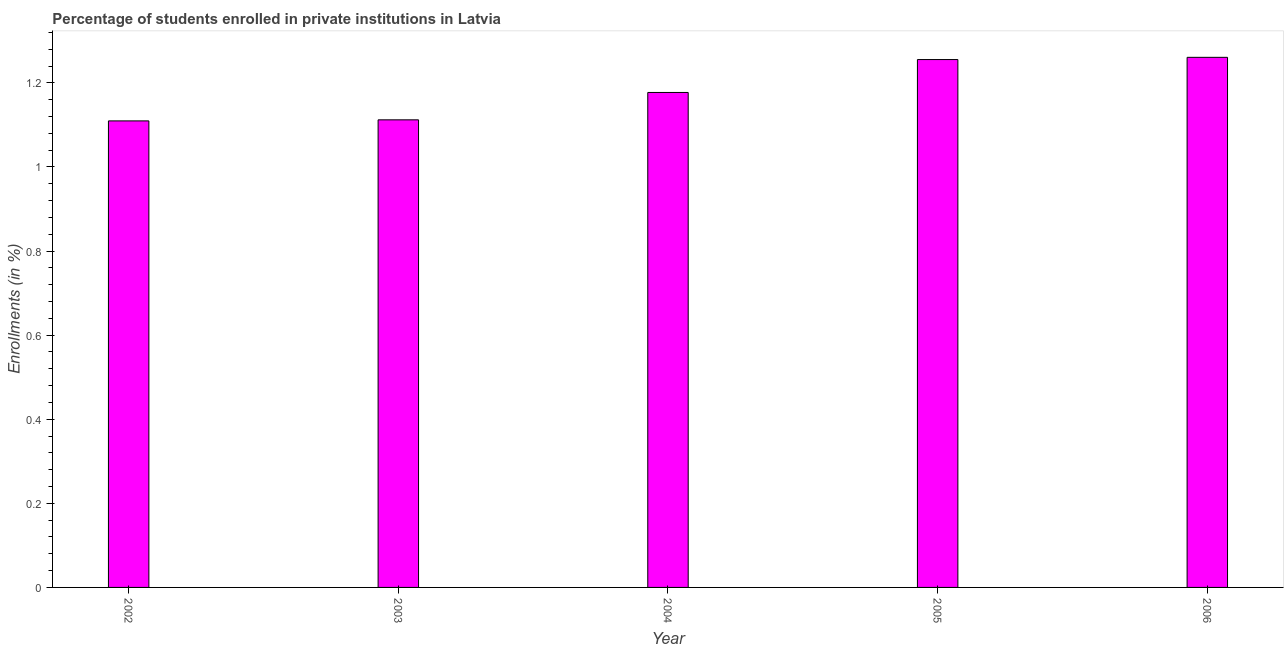What is the title of the graph?
Provide a succinct answer. Percentage of students enrolled in private institutions in Latvia. What is the label or title of the X-axis?
Offer a very short reply. Year. What is the label or title of the Y-axis?
Give a very brief answer. Enrollments (in %). What is the enrollments in private institutions in 2004?
Provide a short and direct response. 1.18. Across all years, what is the maximum enrollments in private institutions?
Your answer should be compact. 1.26. Across all years, what is the minimum enrollments in private institutions?
Make the answer very short. 1.11. In which year was the enrollments in private institutions minimum?
Your answer should be very brief. 2002. What is the sum of the enrollments in private institutions?
Give a very brief answer. 5.91. What is the difference between the enrollments in private institutions in 2002 and 2004?
Your answer should be very brief. -0.07. What is the average enrollments in private institutions per year?
Offer a very short reply. 1.18. What is the median enrollments in private institutions?
Ensure brevity in your answer.  1.18. In how many years, is the enrollments in private institutions greater than 0.32 %?
Give a very brief answer. 5. Do a majority of the years between 2006 and 2004 (inclusive) have enrollments in private institutions greater than 0.84 %?
Offer a very short reply. Yes. What is the ratio of the enrollments in private institutions in 2005 to that in 2006?
Offer a very short reply. 1. Is the enrollments in private institutions in 2002 less than that in 2005?
Your response must be concise. Yes. What is the difference between the highest and the second highest enrollments in private institutions?
Your answer should be compact. 0.01. Is the sum of the enrollments in private institutions in 2002 and 2005 greater than the maximum enrollments in private institutions across all years?
Your answer should be compact. Yes. What is the difference between the highest and the lowest enrollments in private institutions?
Provide a succinct answer. 0.15. Are all the bars in the graph horizontal?
Give a very brief answer. No. What is the difference between two consecutive major ticks on the Y-axis?
Provide a succinct answer. 0.2. What is the Enrollments (in %) of 2002?
Your response must be concise. 1.11. What is the Enrollments (in %) in 2003?
Provide a succinct answer. 1.11. What is the Enrollments (in %) in 2004?
Your answer should be very brief. 1.18. What is the Enrollments (in %) in 2005?
Give a very brief answer. 1.26. What is the Enrollments (in %) of 2006?
Offer a very short reply. 1.26. What is the difference between the Enrollments (in %) in 2002 and 2003?
Provide a short and direct response. -0. What is the difference between the Enrollments (in %) in 2002 and 2004?
Your answer should be compact. -0.07. What is the difference between the Enrollments (in %) in 2002 and 2005?
Your response must be concise. -0.15. What is the difference between the Enrollments (in %) in 2002 and 2006?
Provide a short and direct response. -0.15. What is the difference between the Enrollments (in %) in 2003 and 2004?
Provide a short and direct response. -0.07. What is the difference between the Enrollments (in %) in 2003 and 2005?
Offer a terse response. -0.14. What is the difference between the Enrollments (in %) in 2003 and 2006?
Your answer should be very brief. -0.15. What is the difference between the Enrollments (in %) in 2004 and 2005?
Offer a terse response. -0.08. What is the difference between the Enrollments (in %) in 2004 and 2006?
Make the answer very short. -0.08. What is the difference between the Enrollments (in %) in 2005 and 2006?
Your answer should be compact. -0.01. What is the ratio of the Enrollments (in %) in 2002 to that in 2003?
Provide a succinct answer. 1. What is the ratio of the Enrollments (in %) in 2002 to that in 2004?
Make the answer very short. 0.94. What is the ratio of the Enrollments (in %) in 2002 to that in 2005?
Provide a short and direct response. 0.88. What is the ratio of the Enrollments (in %) in 2003 to that in 2004?
Your answer should be very brief. 0.94. What is the ratio of the Enrollments (in %) in 2003 to that in 2005?
Make the answer very short. 0.89. What is the ratio of the Enrollments (in %) in 2003 to that in 2006?
Provide a short and direct response. 0.88. What is the ratio of the Enrollments (in %) in 2004 to that in 2005?
Keep it short and to the point. 0.94. What is the ratio of the Enrollments (in %) in 2004 to that in 2006?
Your answer should be compact. 0.93. What is the ratio of the Enrollments (in %) in 2005 to that in 2006?
Provide a short and direct response. 1. 